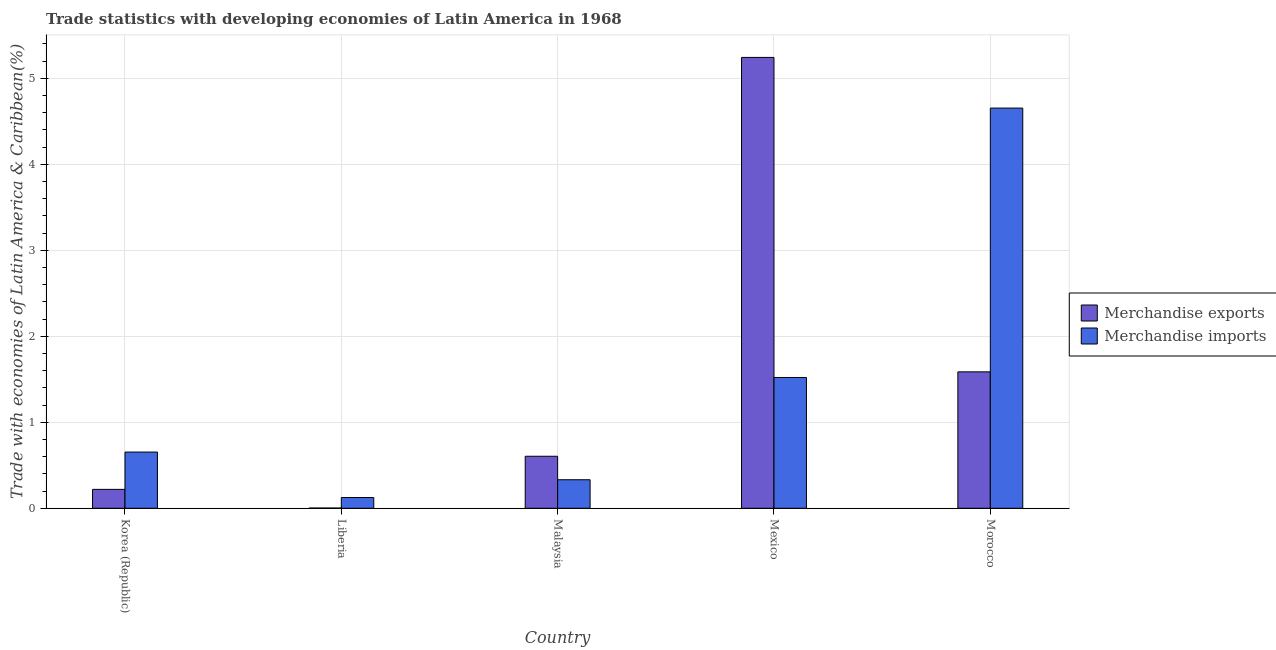Are the number of bars on each tick of the X-axis equal?
Ensure brevity in your answer.  Yes. What is the merchandise imports in Korea (Republic)?
Provide a succinct answer. 0.65. Across all countries, what is the maximum merchandise imports?
Your answer should be very brief. 4.65. Across all countries, what is the minimum merchandise exports?
Offer a very short reply. 0. In which country was the merchandise imports maximum?
Keep it short and to the point. Morocco. In which country was the merchandise imports minimum?
Ensure brevity in your answer.  Liberia. What is the total merchandise imports in the graph?
Your response must be concise. 7.29. What is the difference between the merchandise exports in Liberia and that in Mexico?
Your answer should be compact. -5.24. What is the difference between the merchandise exports in Malaysia and the merchandise imports in Morocco?
Your response must be concise. -4.05. What is the average merchandise exports per country?
Provide a short and direct response. 1.53. What is the difference between the merchandise exports and merchandise imports in Liberia?
Offer a terse response. -0.12. What is the ratio of the merchandise imports in Korea (Republic) to that in Malaysia?
Your answer should be very brief. 1.97. What is the difference between the highest and the second highest merchandise imports?
Keep it short and to the point. 3.13. What is the difference between the highest and the lowest merchandise exports?
Ensure brevity in your answer.  5.24. What does the 1st bar from the left in Korea (Republic) represents?
Provide a short and direct response. Merchandise exports. Are all the bars in the graph horizontal?
Offer a very short reply. No. How many countries are there in the graph?
Provide a short and direct response. 5. Does the graph contain any zero values?
Your answer should be very brief. No. Does the graph contain grids?
Offer a terse response. Yes. How many legend labels are there?
Make the answer very short. 2. What is the title of the graph?
Ensure brevity in your answer.  Trade statistics with developing economies of Latin America in 1968. Does "DAC donors" appear as one of the legend labels in the graph?
Offer a very short reply. No. What is the label or title of the Y-axis?
Give a very brief answer. Trade with economies of Latin America & Caribbean(%). What is the Trade with economies of Latin America & Caribbean(%) of Merchandise exports in Korea (Republic)?
Provide a succinct answer. 0.22. What is the Trade with economies of Latin America & Caribbean(%) of Merchandise imports in Korea (Republic)?
Provide a succinct answer. 0.65. What is the Trade with economies of Latin America & Caribbean(%) of Merchandise exports in Liberia?
Your answer should be very brief. 0. What is the Trade with economies of Latin America & Caribbean(%) in Merchandise imports in Liberia?
Your answer should be compact. 0.12. What is the Trade with economies of Latin America & Caribbean(%) in Merchandise exports in Malaysia?
Keep it short and to the point. 0.6. What is the Trade with economies of Latin America & Caribbean(%) of Merchandise imports in Malaysia?
Your response must be concise. 0.33. What is the Trade with economies of Latin America & Caribbean(%) of Merchandise exports in Mexico?
Provide a succinct answer. 5.24. What is the Trade with economies of Latin America & Caribbean(%) of Merchandise imports in Mexico?
Offer a very short reply. 1.52. What is the Trade with economies of Latin America & Caribbean(%) in Merchandise exports in Morocco?
Make the answer very short. 1.59. What is the Trade with economies of Latin America & Caribbean(%) of Merchandise imports in Morocco?
Provide a succinct answer. 4.65. Across all countries, what is the maximum Trade with economies of Latin America & Caribbean(%) of Merchandise exports?
Give a very brief answer. 5.24. Across all countries, what is the maximum Trade with economies of Latin America & Caribbean(%) in Merchandise imports?
Keep it short and to the point. 4.65. Across all countries, what is the minimum Trade with economies of Latin America & Caribbean(%) of Merchandise exports?
Make the answer very short. 0. Across all countries, what is the minimum Trade with economies of Latin America & Caribbean(%) of Merchandise imports?
Provide a succinct answer. 0.12. What is the total Trade with economies of Latin America & Caribbean(%) of Merchandise exports in the graph?
Your answer should be very brief. 7.66. What is the total Trade with economies of Latin America & Caribbean(%) of Merchandise imports in the graph?
Offer a terse response. 7.29. What is the difference between the Trade with economies of Latin America & Caribbean(%) in Merchandise exports in Korea (Republic) and that in Liberia?
Your answer should be compact. 0.22. What is the difference between the Trade with economies of Latin America & Caribbean(%) in Merchandise imports in Korea (Republic) and that in Liberia?
Offer a very short reply. 0.53. What is the difference between the Trade with economies of Latin America & Caribbean(%) in Merchandise exports in Korea (Republic) and that in Malaysia?
Give a very brief answer. -0.39. What is the difference between the Trade with economies of Latin America & Caribbean(%) of Merchandise imports in Korea (Republic) and that in Malaysia?
Ensure brevity in your answer.  0.32. What is the difference between the Trade with economies of Latin America & Caribbean(%) of Merchandise exports in Korea (Republic) and that in Mexico?
Offer a very short reply. -5.02. What is the difference between the Trade with economies of Latin America & Caribbean(%) in Merchandise imports in Korea (Republic) and that in Mexico?
Your answer should be compact. -0.87. What is the difference between the Trade with economies of Latin America & Caribbean(%) in Merchandise exports in Korea (Republic) and that in Morocco?
Offer a terse response. -1.37. What is the difference between the Trade with economies of Latin America & Caribbean(%) in Merchandise imports in Korea (Republic) and that in Morocco?
Provide a succinct answer. -4. What is the difference between the Trade with economies of Latin America & Caribbean(%) in Merchandise exports in Liberia and that in Malaysia?
Your answer should be very brief. -0.6. What is the difference between the Trade with economies of Latin America & Caribbean(%) of Merchandise imports in Liberia and that in Malaysia?
Offer a terse response. -0.21. What is the difference between the Trade with economies of Latin America & Caribbean(%) in Merchandise exports in Liberia and that in Mexico?
Your answer should be very brief. -5.24. What is the difference between the Trade with economies of Latin America & Caribbean(%) in Merchandise imports in Liberia and that in Mexico?
Your response must be concise. -1.4. What is the difference between the Trade with economies of Latin America & Caribbean(%) of Merchandise exports in Liberia and that in Morocco?
Your answer should be very brief. -1.58. What is the difference between the Trade with economies of Latin America & Caribbean(%) in Merchandise imports in Liberia and that in Morocco?
Your response must be concise. -4.53. What is the difference between the Trade with economies of Latin America & Caribbean(%) of Merchandise exports in Malaysia and that in Mexico?
Give a very brief answer. -4.64. What is the difference between the Trade with economies of Latin America & Caribbean(%) in Merchandise imports in Malaysia and that in Mexico?
Offer a terse response. -1.19. What is the difference between the Trade with economies of Latin America & Caribbean(%) in Merchandise exports in Malaysia and that in Morocco?
Ensure brevity in your answer.  -0.98. What is the difference between the Trade with economies of Latin America & Caribbean(%) of Merchandise imports in Malaysia and that in Morocco?
Provide a succinct answer. -4.32. What is the difference between the Trade with economies of Latin America & Caribbean(%) in Merchandise exports in Mexico and that in Morocco?
Provide a succinct answer. 3.66. What is the difference between the Trade with economies of Latin America & Caribbean(%) in Merchandise imports in Mexico and that in Morocco?
Your response must be concise. -3.13. What is the difference between the Trade with economies of Latin America & Caribbean(%) in Merchandise exports in Korea (Republic) and the Trade with economies of Latin America & Caribbean(%) in Merchandise imports in Liberia?
Make the answer very short. 0.09. What is the difference between the Trade with economies of Latin America & Caribbean(%) in Merchandise exports in Korea (Republic) and the Trade with economies of Latin America & Caribbean(%) in Merchandise imports in Malaysia?
Your answer should be very brief. -0.11. What is the difference between the Trade with economies of Latin America & Caribbean(%) in Merchandise exports in Korea (Republic) and the Trade with economies of Latin America & Caribbean(%) in Merchandise imports in Mexico?
Provide a short and direct response. -1.3. What is the difference between the Trade with economies of Latin America & Caribbean(%) of Merchandise exports in Korea (Republic) and the Trade with economies of Latin America & Caribbean(%) of Merchandise imports in Morocco?
Provide a short and direct response. -4.43. What is the difference between the Trade with economies of Latin America & Caribbean(%) in Merchandise exports in Liberia and the Trade with economies of Latin America & Caribbean(%) in Merchandise imports in Malaysia?
Keep it short and to the point. -0.33. What is the difference between the Trade with economies of Latin America & Caribbean(%) in Merchandise exports in Liberia and the Trade with economies of Latin America & Caribbean(%) in Merchandise imports in Mexico?
Offer a terse response. -1.52. What is the difference between the Trade with economies of Latin America & Caribbean(%) in Merchandise exports in Liberia and the Trade with economies of Latin America & Caribbean(%) in Merchandise imports in Morocco?
Provide a short and direct response. -4.65. What is the difference between the Trade with economies of Latin America & Caribbean(%) of Merchandise exports in Malaysia and the Trade with economies of Latin America & Caribbean(%) of Merchandise imports in Mexico?
Make the answer very short. -0.92. What is the difference between the Trade with economies of Latin America & Caribbean(%) of Merchandise exports in Malaysia and the Trade with economies of Latin America & Caribbean(%) of Merchandise imports in Morocco?
Provide a short and direct response. -4.05. What is the difference between the Trade with economies of Latin America & Caribbean(%) in Merchandise exports in Mexico and the Trade with economies of Latin America & Caribbean(%) in Merchandise imports in Morocco?
Give a very brief answer. 0.59. What is the average Trade with economies of Latin America & Caribbean(%) of Merchandise exports per country?
Provide a short and direct response. 1.53. What is the average Trade with economies of Latin America & Caribbean(%) of Merchandise imports per country?
Provide a succinct answer. 1.46. What is the difference between the Trade with economies of Latin America & Caribbean(%) of Merchandise exports and Trade with economies of Latin America & Caribbean(%) of Merchandise imports in Korea (Republic)?
Provide a short and direct response. -0.43. What is the difference between the Trade with economies of Latin America & Caribbean(%) of Merchandise exports and Trade with economies of Latin America & Caribbean(%) of Merchandise imports in Liberia?
Offer a terse response. -0.12. What is the difference between the Trade with economies of Latin America & Caribbean(%) in Merchandise exports and Trade with economies of Latin America & Caribbean(%) in Merchandise imports in Malaysia?
Your answer should be compact. 0.27. What is the difference between the Trade with economies of Latin America & Caribbean(%) of Merchandise exports and Trade with economies of Latin America & Caribbean(%) of Merchandise imports in Mexico?
Keep it short and to the point. 3.72. What is the difference between the Trade with economies of Latin America & Caribbean(%) of Merchandise exports and Trade with economies of Latin America & Caribbean(%) of Merchandise imports in Morocco?
Your answer should be very brief. -3.07. What is the ratio of the Trade with economies of Latin America & Caribbean(%) in Merchandise exports in Korea (Republic) to that in Liberia?
Give a very brief answer. 87.75. What is the ratio of the Trade with economies of Latin America & Caribbean(%) in Merchandise imports in Korea (Republic) to that in Liberia?
Your answer should be very brief. 5.23. What is the ratio of the Trade with economies of Latin America & Caribbean(%) of Merchandise exports in Korea (Republic) to that in Malaysia?
Give a very brief answer. 0.36. What is the ratio of the Trade with economies of Latin America & Caribbean(%) in Merchandise imports in Korea (Republic) to that in Malaysia?
Ensure brevity in your answer.  1.97. What is the ratio of the Trade with economies of Latin America & Caribbean(%) of Merchandise exports in Korea (Republic) to that in Mexico?
Provide a short and direct response. 0.04. What is the ratio of the Trade with economies of Latin America & Caribbean(%) in Merchandise imports in Korea (Republic) to that in Mexico?
Make the answer very short. 0.43. What is the ratio of the Trade with economies of Latin America & Caribbean(%) of Merchandise exports in Korea (Republic) to that in Morocco?
Provide a succinct answer. 0.14. What is the ratio of the Trade with economies of Latin America & Caribbean(%) of Merchandise imports in Korea (Republic) to that in Morocco?
Offer a very short reply. 0.14. What is the ratio of the Trade with economies of Latin America & Caribbean(%) of Merchandise exports in Liberia to that in Malaysia?
Ensure brevity in your answer.  0. What is the ratio of the Trade with economies of Latin America & Caribbean(%) of Merchandise imports in Liberia to that in Malaysia?
Your answer should be compact. 0.38. What is the ratio of the Trade with economies of Latin America & Caribbean(%) of Merchandise exports in Liberia to that in Mexico?
Make the answer very short. 0. What is the ratio of the Trade with economies of Latin America & Caribbean(%) in Merchandise imports in Liberia to that in Mexico?
Ensure brevity in your answer.  0.08. What is the ratio of the Trade with economies of Latin America & Caribbean(%) in Merchandise exports in Liberia to that in Morocco?
Make the answer very short. 0. What is the ratio of the Trade with economies of Latin America & Caribbean(%) in Merchandise imports in Liberia to that in Morocco?
Offer a very short reply. 0.03. What is the ratio of the Trade with economies of Latin America & Caribbean(%) in Merchandise exports in Malaysia to that in Mexico?
Offer a very short reply. 0.12. What is the ratio of the Trade with economies of Latin America & Caribbean(%) in Merchandise imports in Malaysia to that in Mexico?
Your answer should be very brief. 0.22. What is the ratio of the Trade with economies of Latin America & Caribbean(%) in Merchandise exports in Malaysia to that in Morocco?
Ensure brevity in your answer.  0.38. What is the ratio of the Trade with economies of Latin America & Caribbean(%) in Merchandise imports in Malaysia to that in Morocco?
Offer a terse response. 0.07. What is the ratio of the Trade with economies of Latin America & Caribbean(%) of Merchandise exports in Mexico to that in Morocco?
Keep it short and to the point. 3.3. What is the ratio of the Trade with economies of Latin America & Caribbean(%) of Merchandise imports in Mexico to that in Morocco?
Keep it short and to the point. 0.33. What is the difference between the highest and the second highest Trade with economies of Latin America & Caribbean(%) in Merchandise exports?
Your answer should be very brief. 3.66. What is the difference between the highest and the second highest Trade with economies of Latin America & Caribbean(%) of Merchandise imports?
Offer a terse response. 3.13. What is the difference between the highest and the lowest Trade with economies of Latin America & Caribbean(%) of Merchandise exports?
Make the answer very short. 5.24. What is the difference between the highest and the lowest Trade with economies of Latin America & Caribbean(%) of Merchandise imports?
Offer a terse response. 4.53. 